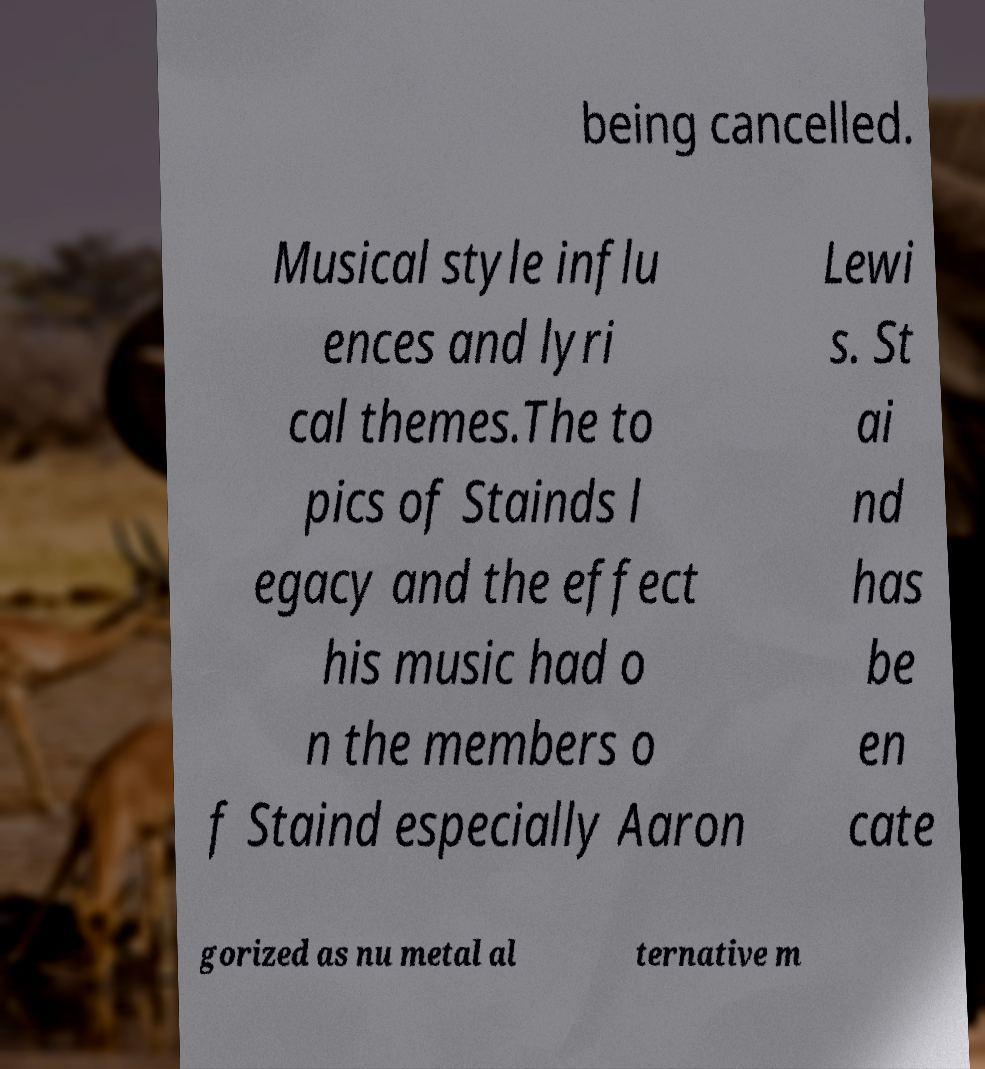Can you accurately transcribe the text from the provided image for me? being cancelled. Musical style influ ences and lyri cal themes.The to pics of Stainds l egacy and the effect his music had o n the members o f Staind especially Aaron Lewi s. St ai nd has be en cate gorized as nu metal al ternative m 